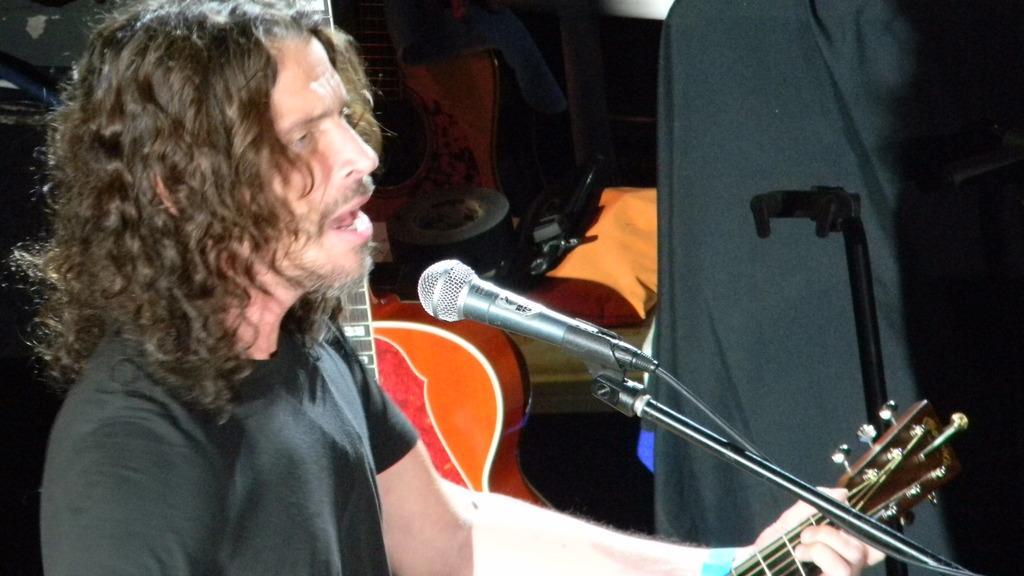In one or two sentences, can you explain what this image depicts? In this picture we can see a person, here we can see a mic, guitars and some objects. 